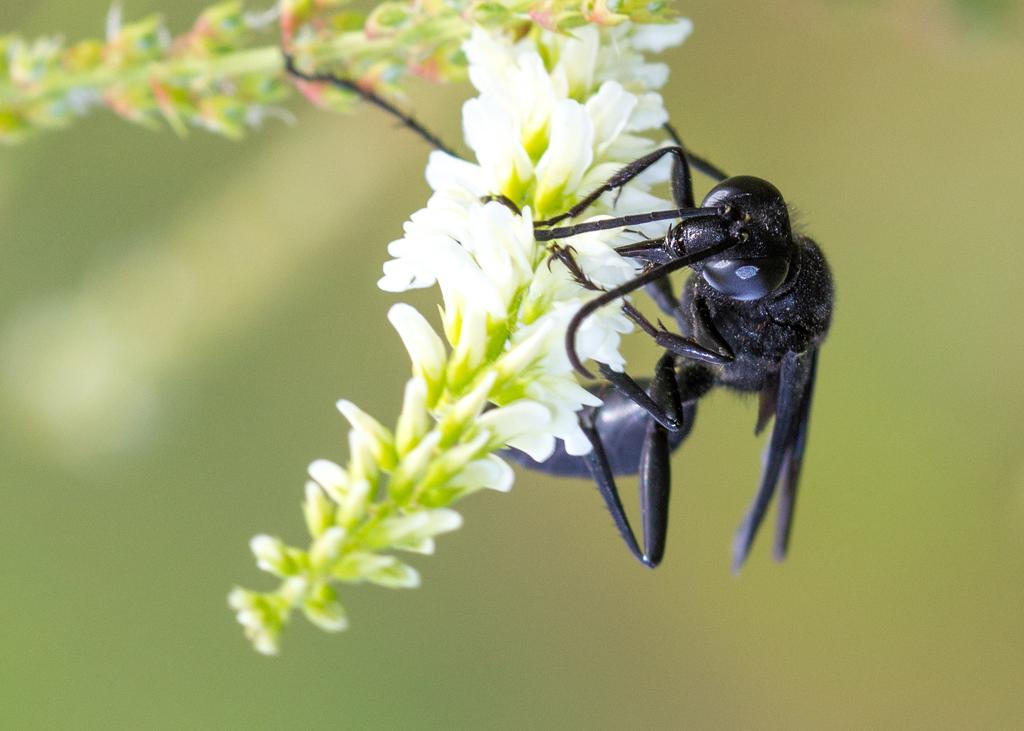What type of plant can be seen in the image? There is a flowering plant in the image. Are there any animals or insects visible in the image? Yes, there is an ant in the image. What color is predominant in the background of the image? The background of the image is green. Can you determine the time of day when the image was taken? The image was likely taken during the day, as there is sufficient light to see the plant and ant clearly. What type of tax is being discussed in the image? There is no discussion of tax in the image; it features a flowering plant and an ant. Who needs to approve the oven in the image? There is no oven present in the image. 